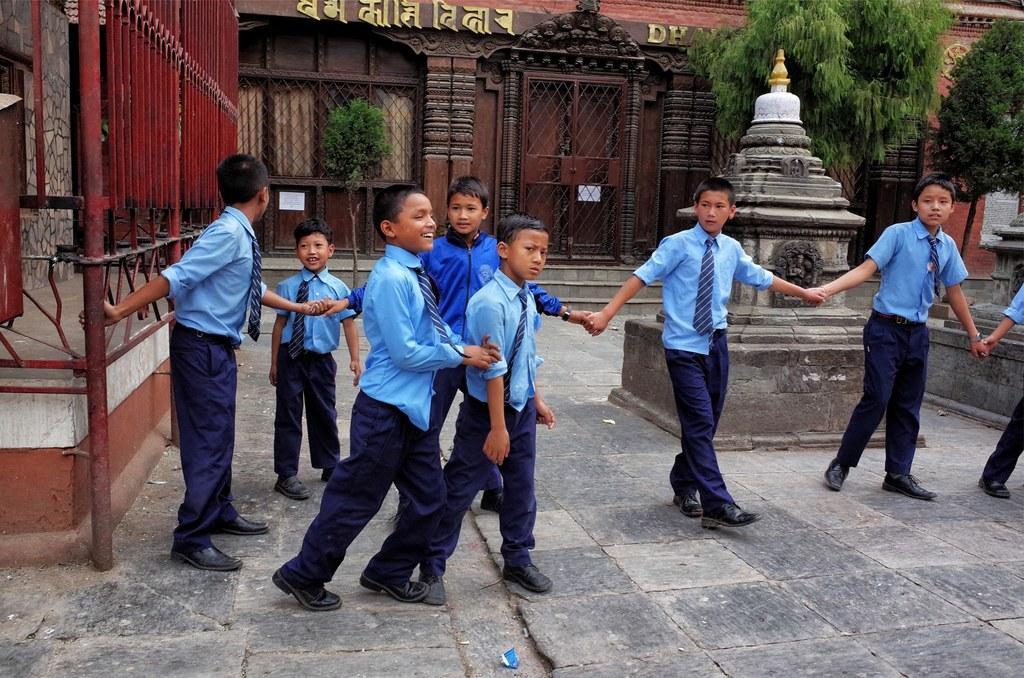Please provide a concise description of this image. In this image I can see a group of boys are walking on the floor. In the background I can see buildings, fence, metal rods, doors, house plants, trees and a temple. This image is taken may be during a day. 